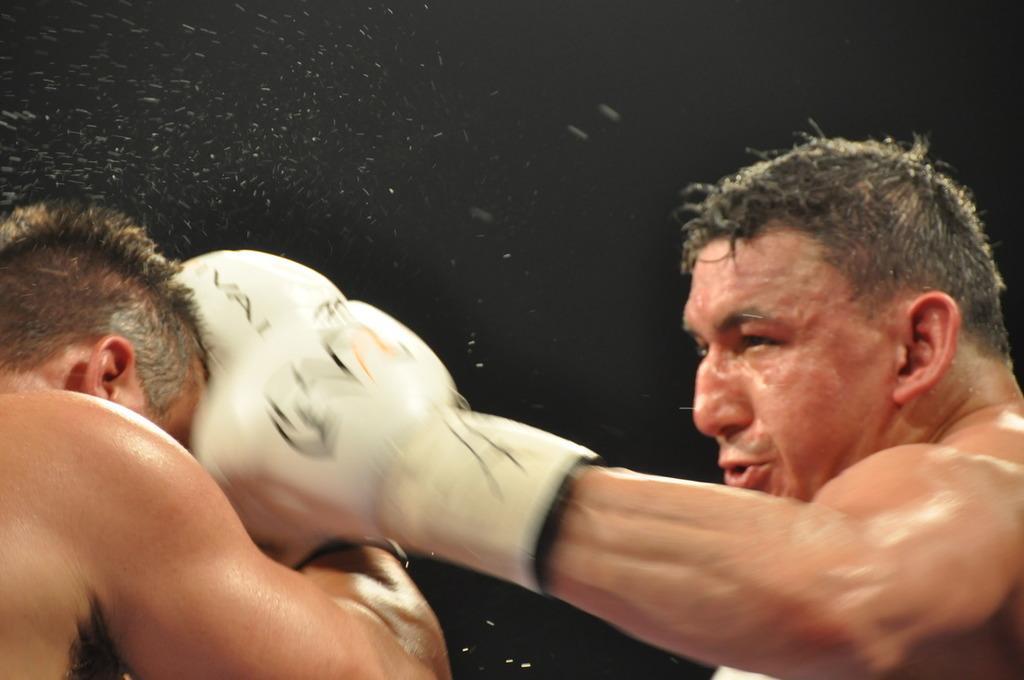How would you summarize this image in a sentence or two? In this image we can see two people boxing. 